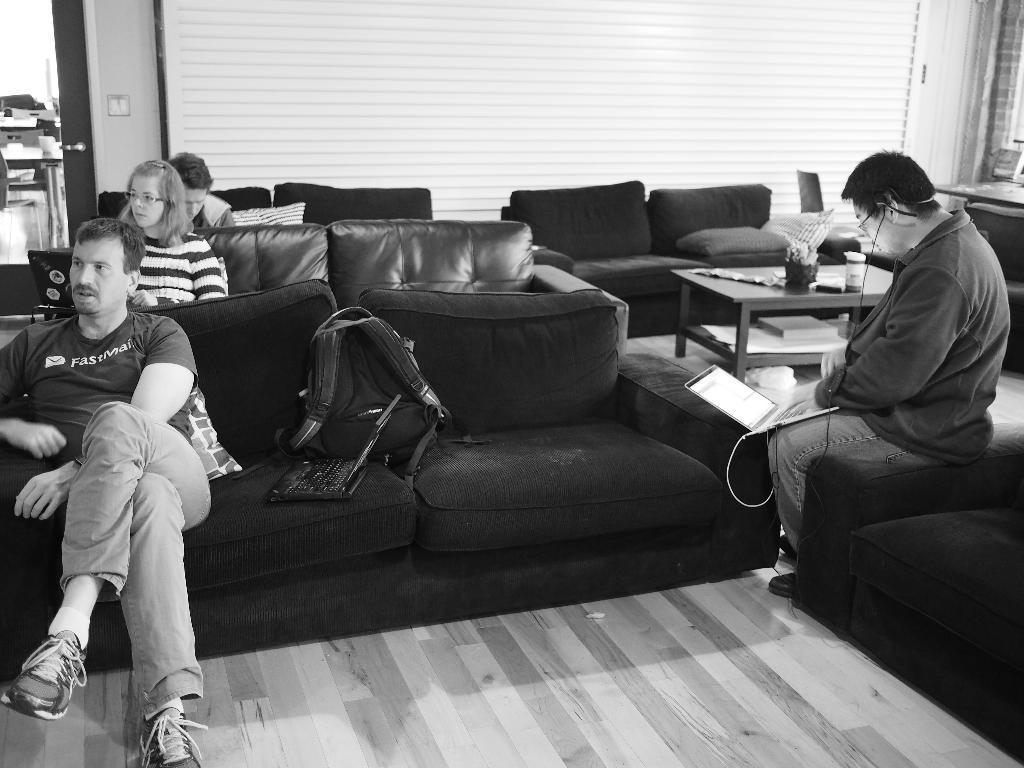Please provide a concise description of this image. On the right there is a man he is typing something on the laptop. On the left there are three people sitting on the sofas. In the middle there is a table on that there is a bottle and flower vase. 